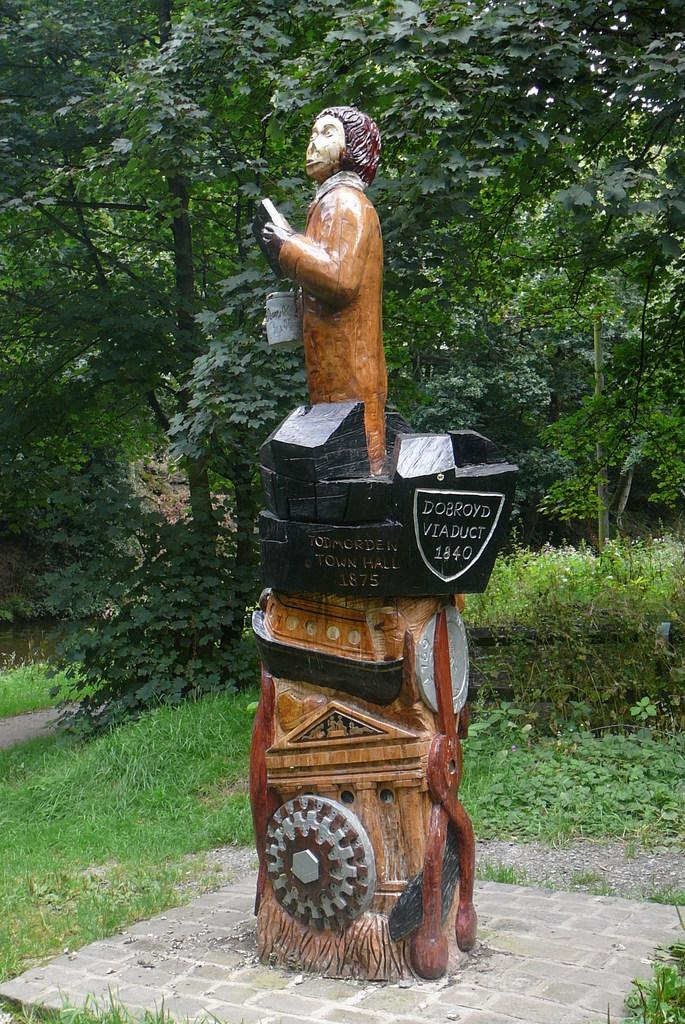What is the main subject in the center of the image? There is a statue in the center of the image. What can be seen on the statue? The statue has some text on it. What type of natural environment is visible in the background of the image? There are trees, grass, and plants in the background of the image. Can you see a hat on the statue in the image? There is no hat visible on the statue in the image. How many snails can be seen crawling on the statue in the image? There are no snails present in the image. 